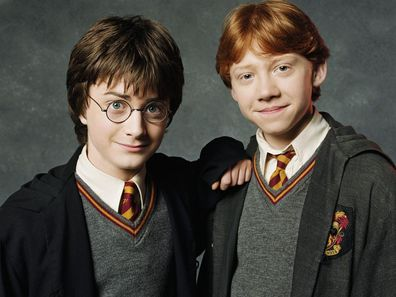Imagine this scene happening in another location. Describe it in detail. Imagine this scene is happening in the cozy Gryffindor common room. Harry and Ron stand by the roaring fireplace, its flickering light casting warm shadows on their faces. The room is filled with plush armchairs and sofas, with fellow Gryffindor students relaxing and chatting in the background. Soft, golden light from enchanted lamps illuminates the red and gold decor, with banners bearing the Gryffindor lion hanging proudly on the walls. Beside them, Crookshanks, Hermione's cat, curls up in a corner, and the atmosphere is filled with the comforting hum of friendly banter and the crackle of the fire. 